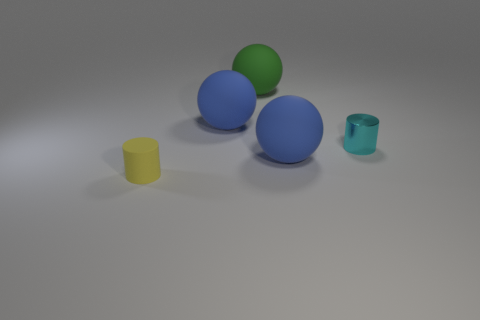Subtract all blue spheres. How many spheres are left? 1 Add 3 tiny cyan metal cylinders. How many objects exist? 8 Subtract all cylinders. How many objects are left? 3 Add 3 small things. How many small things are left? 5 Add 5 blue matte balls. How many blue matte balls exist? 7 Subtract 0 gray cubes. How many objects are left? 5 Subtract all yellow objects. Subtract all rubber balls. How many objects are left? 1 